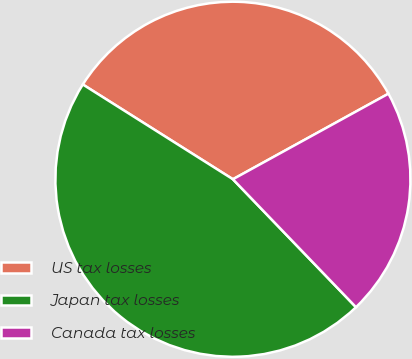<chart> <loc_0><loc_0><loc_500><loc_500><pie_chart><fcel>US tax losses<fcel>Japan tax losses<fcel>Canada tax losses<nl><fcel>33.03%<fcel>46.15%<fcel>20.81%<nl></chart> 